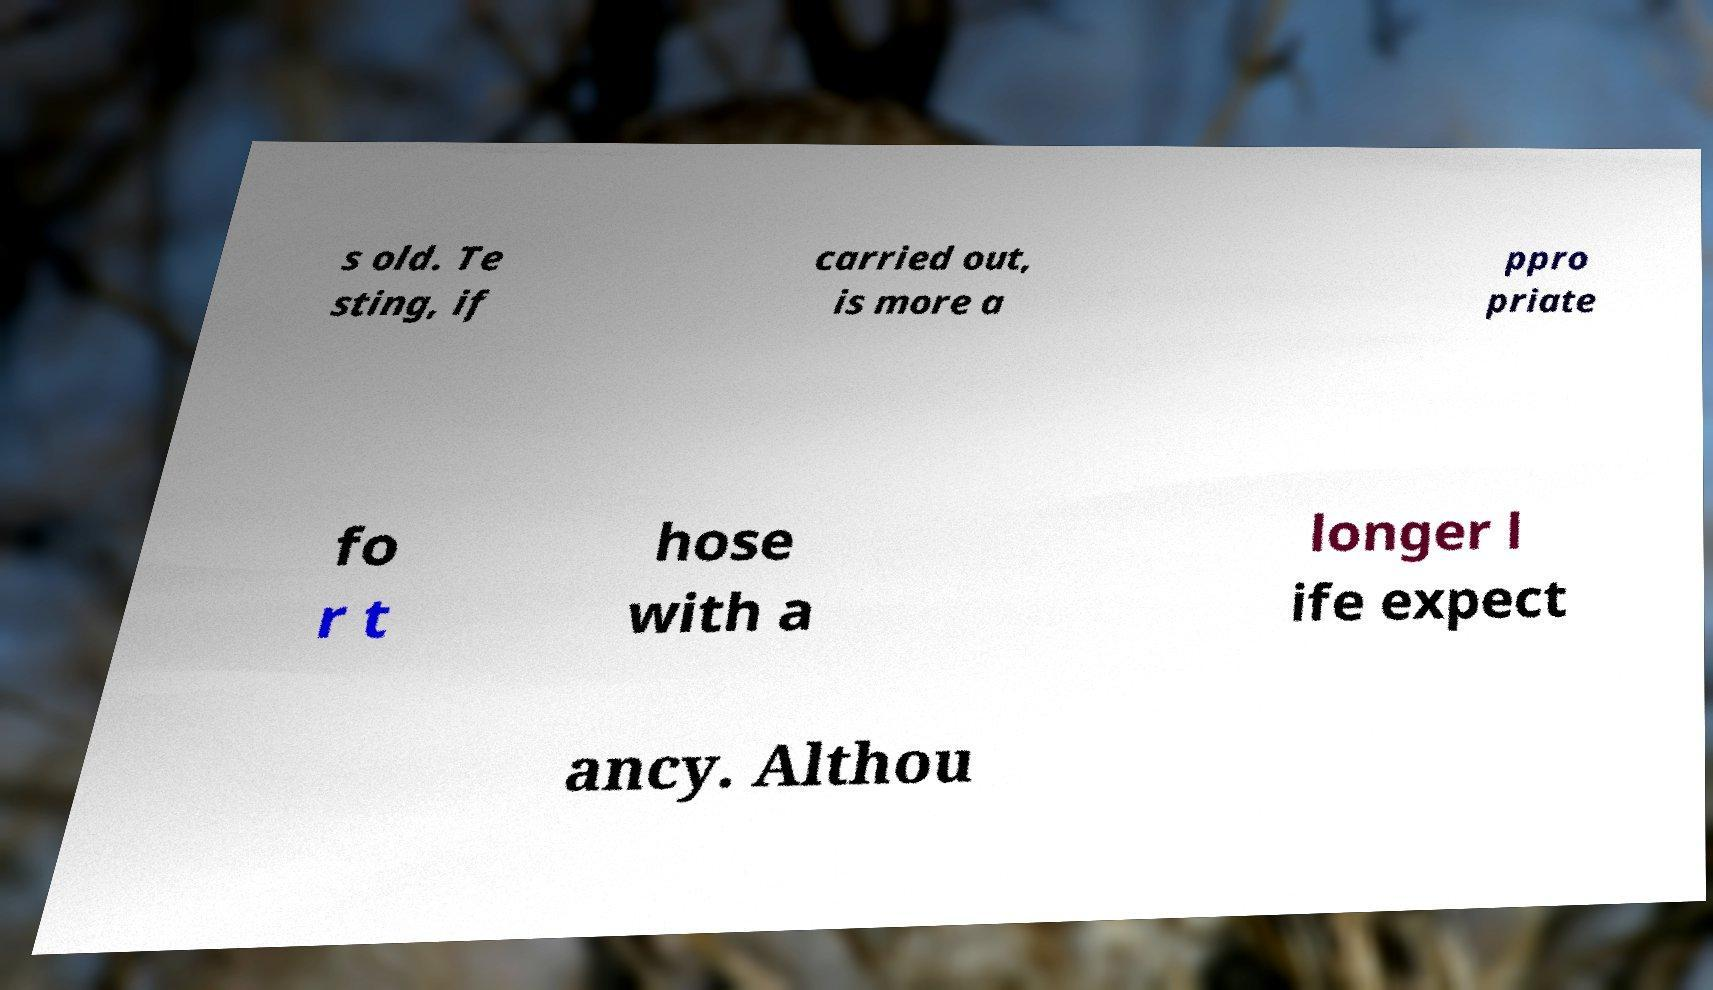Could you assist in decoding the text presented in this image and type it out clearly? s old. Te sting, if carried out, is more a ppro priate fo r t hose with a longer l ife expect ancy. Althou 